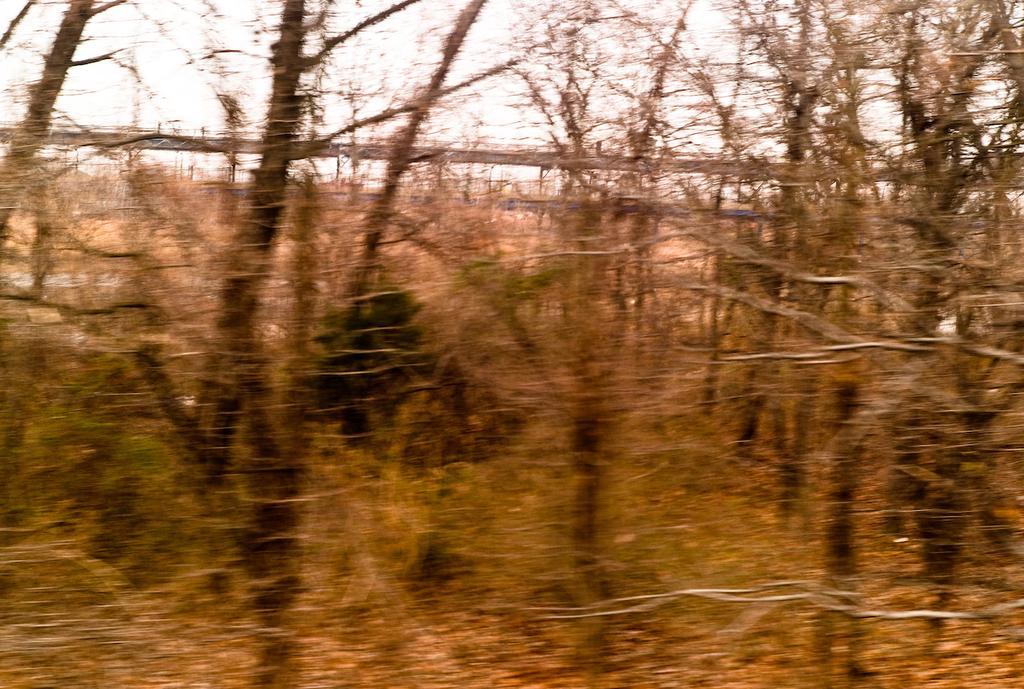How would you summarize this image in a sentence or two? In the center of the image there are trees. In the background we can see a fence. 